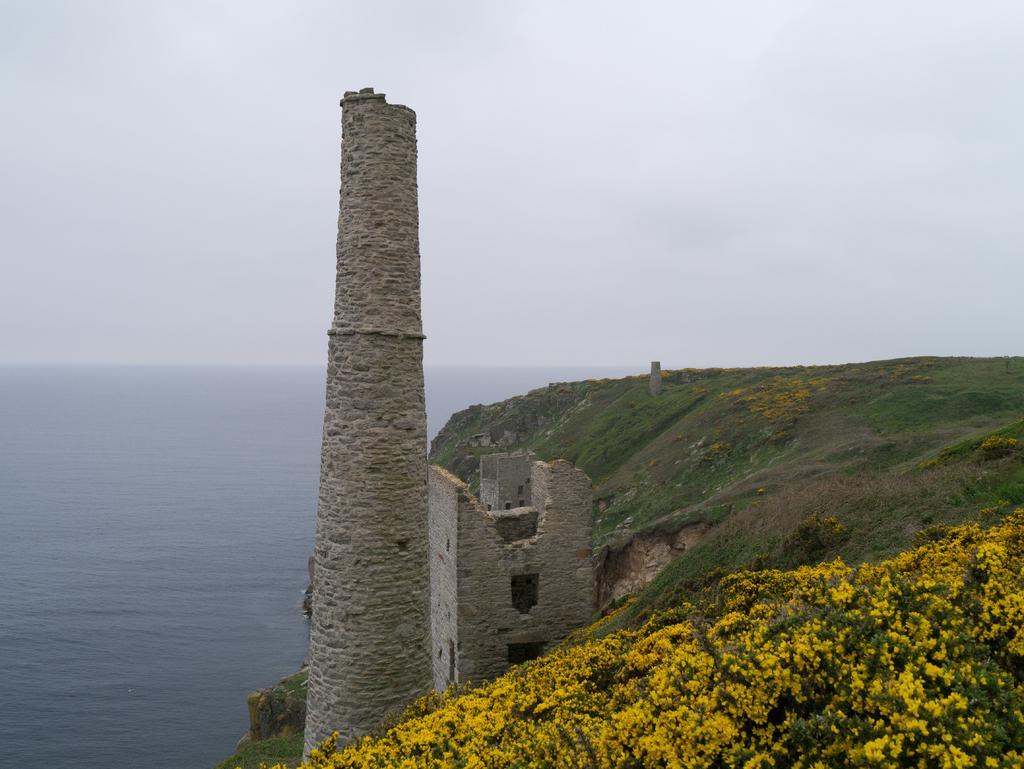How would you summarize this image in a sentence or two? In this image I can see a tower. Background I can see grass in green color, flowers in yellow color and sky in white color. 